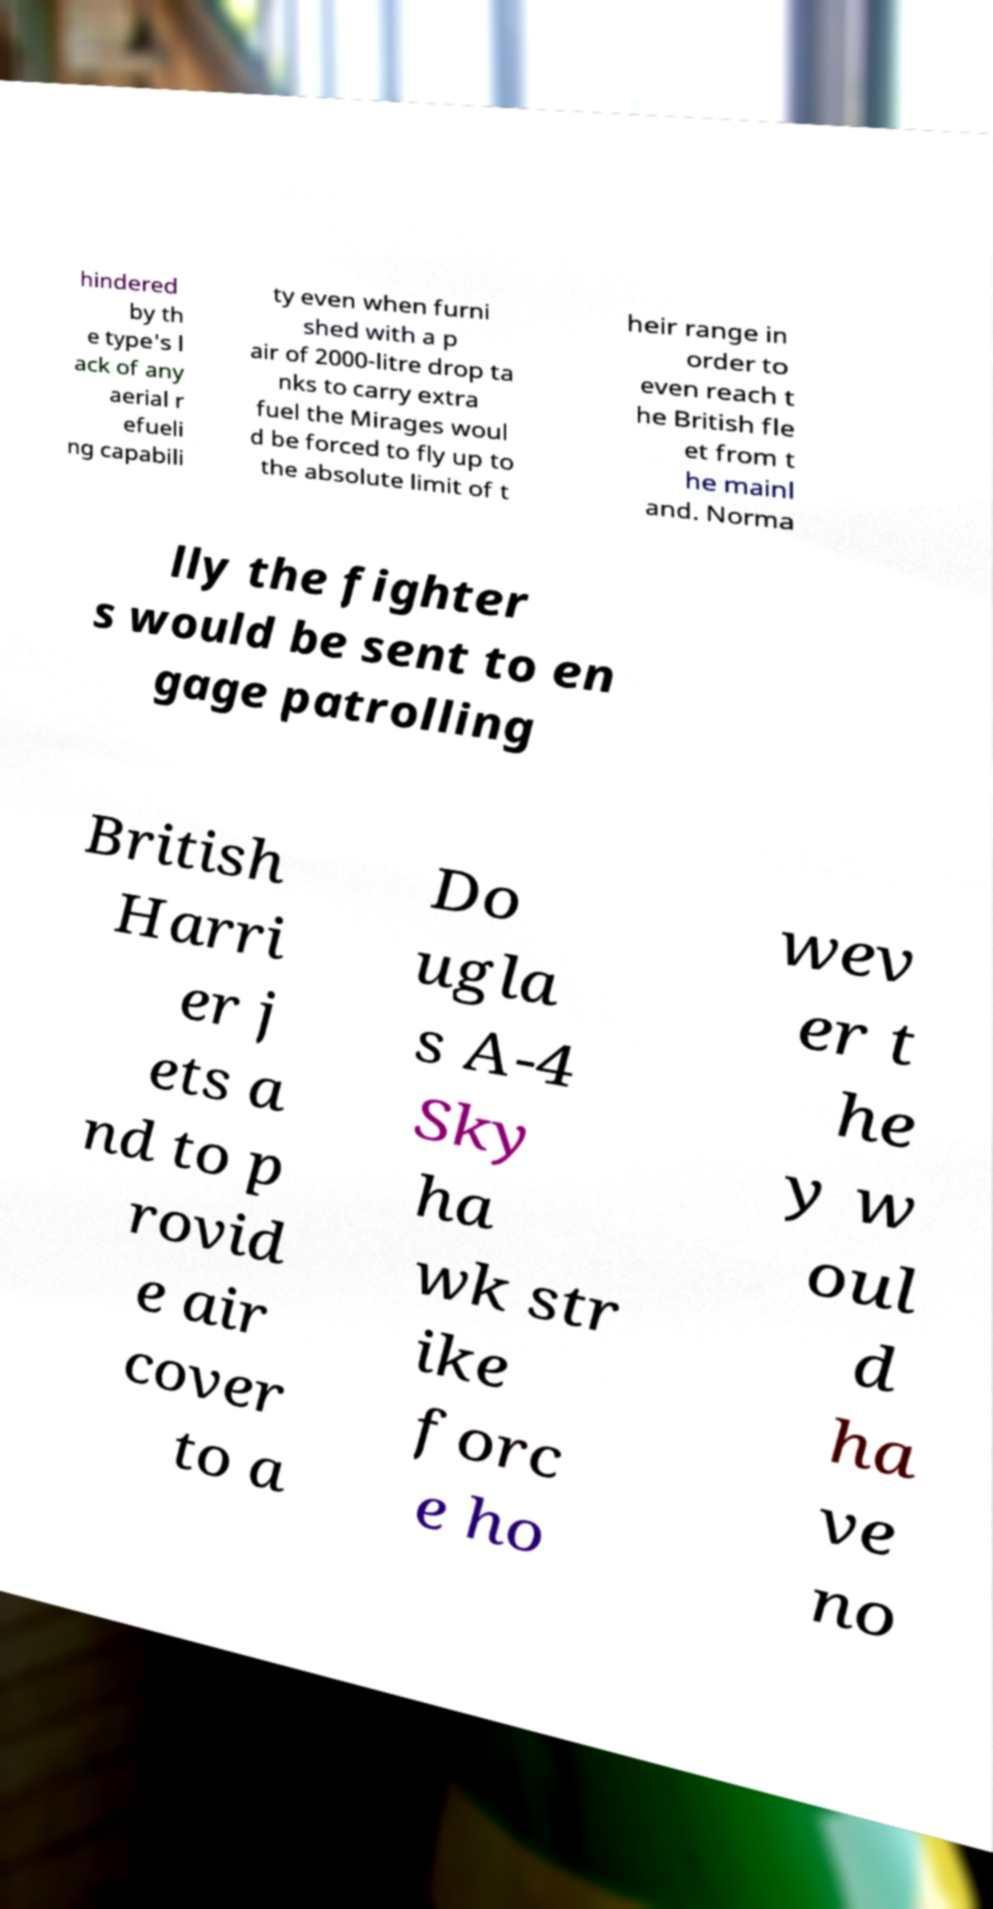There's text embedded in this image that I need extracted. Can you transcribe it verbatim? hindered by th e type's l ack of any aerial r efueli ng capabili ty even when furni shed with a p air of 2000-litre drop ta nks to carry extra fuel the Mirages woul d be forced to fly up to the absolute limit of t heir range in order to even reach t he British fle et from t he mainl and. Norma lly the fighter s would be sent to en gage patrolling British Harri er j ets a nd to p rovid e air cover to a Do ugla s A-4 Sky ha wk str ike forc e ho wev er t he y w oul d ha ve no 